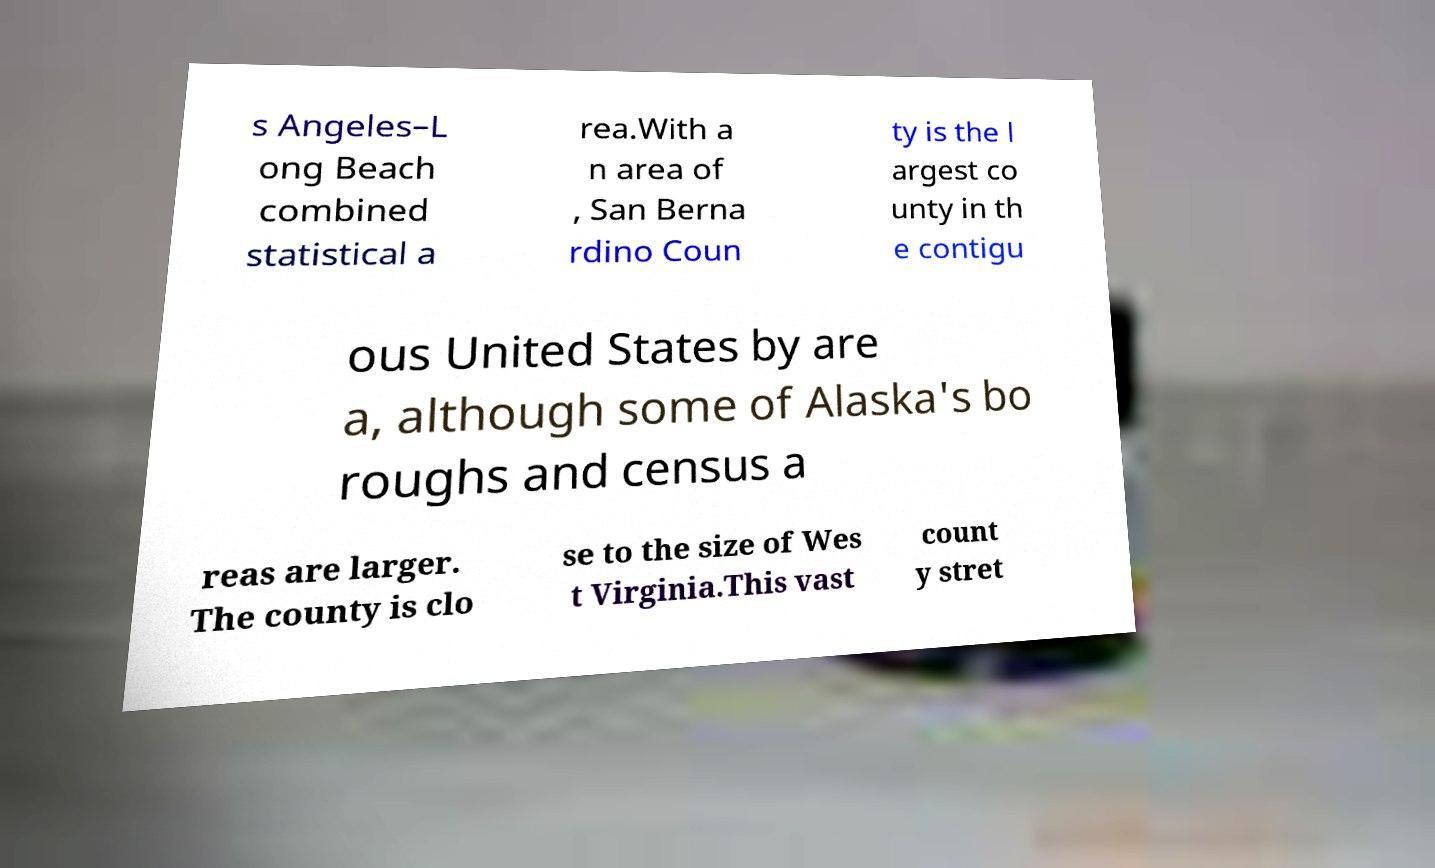Please identify and transcribe the text found in this image. s Angeles–L ong Beach combined statistical a rea.With a n area of , San Berna rdino Coun ty is the l argest co unty in th e contigu ous United States by are a, although some of Alaska's bo roughs and census a reas are larger. The county is clo se to the size of Wes t Virginia.This vast count y stret 